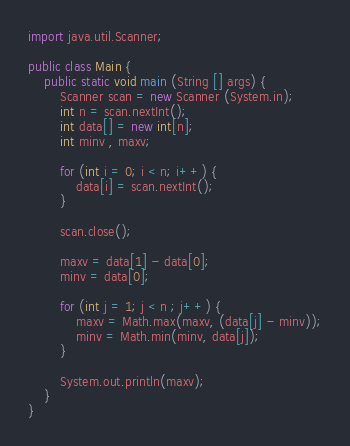<code> <loc_0><loc_0><loc_500><loc_500><_Java_>import java.util.Scanner;

public class Main {
	public static void main (String [] args) {
		Scanner scan = new Scanner (System.in);
		int n = scan.nextInt();
		int data[] = new int[n];
		int minv , maxv;
		
		for (int i = 0; i < n; i++) {
			data[i] = scan.nextInt();
		}
		
		scan.close();
		
		maxv = data[1] - data[0];
		minv = data[0];
		
		for (int j = 1; j < n ; j++) {
			maxv = Math.max(maxv, (data[j] - minv));
			minv = Math.min(minv, data[j]);
		}
		
		System.out.println(maxv);
	}
}

</code> 